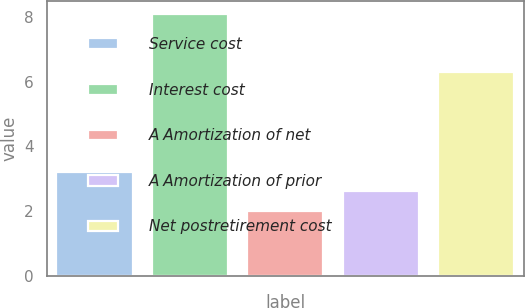Convert chart. <chart><loc_0><loc_0><loc_500><loc_500><bar_chart><fcel>Service cost<fcel>Interest cost<fcel>A Amortization of net<fcel>A Amortization of prior<fcel>Net postretirement cost<nl><fcel>3.22<fcel>8.1<fcel>2<fcel>2.61<fcel>6.3<nl></chart> 